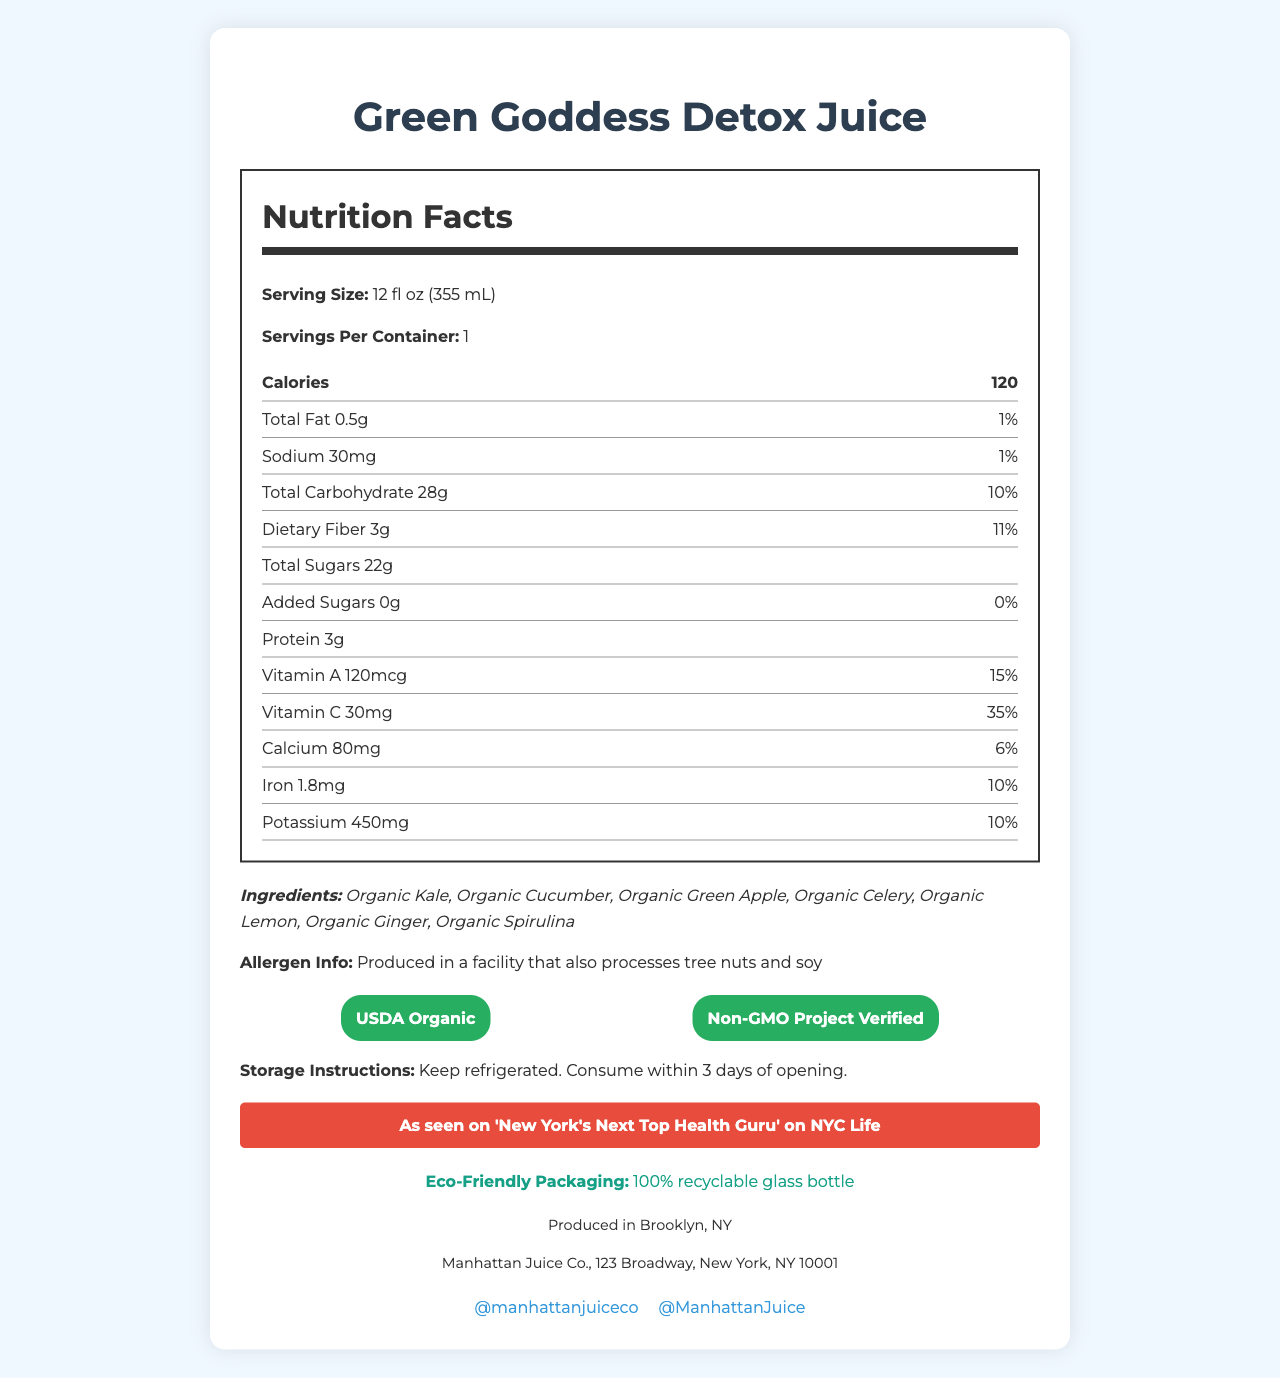what is the name of the product? The name of the product is displayed prominently at the top of the document.
Answer: Green Goddess Detox Juice what is the serving size of the juice? The serving size is listed under the Nutrition Facts section.
Answer: 12 fl oz (355 mL) how many calories are in one serving? The number of calories per serving is listed in bold in the Nutrition Facts section.
Answer: 120 how much protein does each serving contain? The amount of protein per serving is provided in the Nutrition Facts section.
Answer: 3g what are the ingredients in the juice? The list of ingredients is displayed in the ingredients section beneath the Nutrition Facts.
Answer: Organic Kale, Organic Cucumber, Organic Green Apple, Organic Celery, Organic Lemon, Organic Ginger, Organic Spirulina where is the juice produced? The manufacturing location is provided at the bottom of the document in the contact info section.
Answer: Brooklyn, NY what is the total fat content and its daily value percentage? The total fat amount and daily value percentage are listed in the Nutrition Facts section.
Answer: 0.5g, 1% what certifications does the product have? A. FDA Approved B. Non-GMO Project Verified C. USDA Organic D. Certified Vegan The product is certified by Non-GMO Project Verified and USDA Organic, as indicated by the badges in the certifications section.
Answer: B, C which social media platforms is the brand active on? A. Facebook B. Instagram C. Twitter D. LinkedIn The brand is active on Instagram (@manhattanjuiceco) and Twitter (@ManhattanJuice), which are listed in the social media section.
Answer: B, C does the product contain any added sugars? The Nutrition Facts label indicates that the amount of added sugars is 0g.
Answer: No is the product eco-friendly? The document mentions that the product uses 100% recyclable glass bottle packaging.
Answer: Yes what is the main idea of the document? The document is designed to inform consumers about the nutritional content, ingredients, certifications, and other relevant details about the juice.
Answer: The document provides detailed information about the Green Goddess Detox Juice by Manhattan Juice Co., including its nutrition facts, ingredients, certifications, allergen information, storage instructions, manufacturing location, and contact info. what TV show featured the product? The product was featured on "New York's Next Top Health Guru" as indicated in the tv feature section.
Answer: 'New York's Next Top Health Guru' on NYC Life how much vitamin C is in one serving? The amount of vitamin C and its daily value percentage are listed in the Nutrition Facts section.
Answer: 30mg, 35% Daily Value how long should the juice be consumed after opening? The storage instructions mention to consume the juice within 3 days of opening.
Answer: 3 days how can you contact the company? The contact information is provided at the bottom of the document.
Answer: Manhattan Juice Co., 123 Broadway, New York, NY 10001 based on the visual information, what is the cost of the juice? The document does not provide any information regarding the cost of the juice, so it cannot be determined from the visual information available.
Answer: Not enough information 